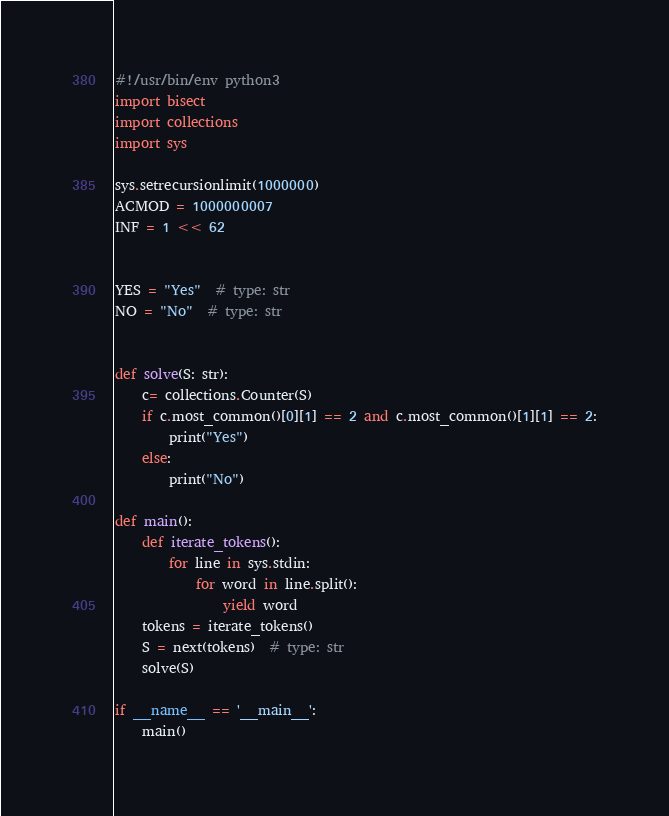Convert code to text. <code><loc_0><loc_0><loc_500><loc_500><_Python_>#!/usr/bin/env python3
import bisect
import collections
import sys

sys.setrecursionlimit(1000000)
ACMOD = 1000000007
INF = 1 << 62


YES = "Yes"  # type: str
NO = "No"  # type: str


def solve(S: str):
    c= collections.Counter(S)
    if c.most_common()[0][1] == 2 and c.most_common()[1][1] == 2:
        print("Yes")
    else:
        print("No")

def main():
    def iterate_tokens():
        for line in sys.stdin:
            for word in line.split():
                yield word
    tokens = iterate_tokens()
    S = next(tokens)  # type: str
    solve(S)

if __name__ == '__main__':
    main()
</code> 